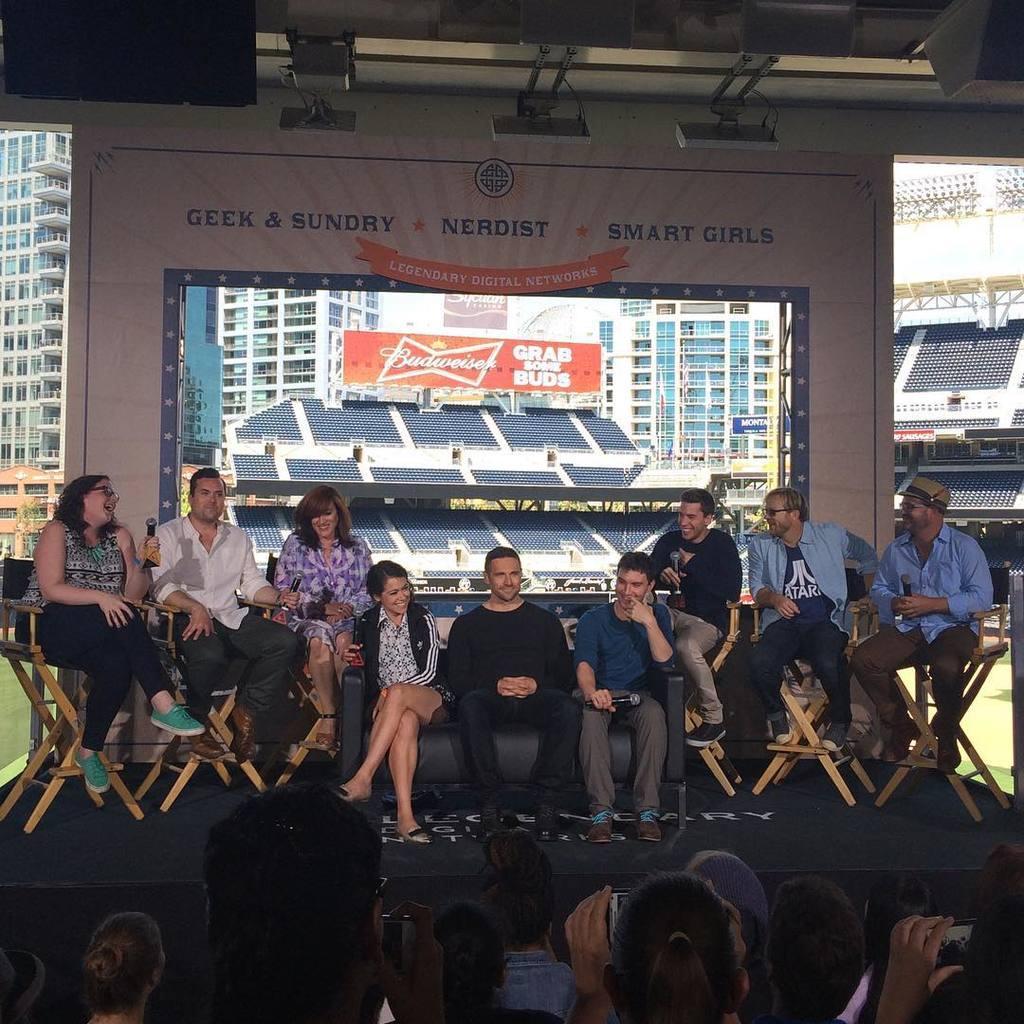How would you summarize this image in a sentence or two? In the image in the center, we can see a few people are sitting and they are smiling, which we can see on their faces. In the bottom of the image we can see a few people standing and holding phones. In the background there is a wall, one banner and screens. On the screens, we can see buildings, banners etc. 